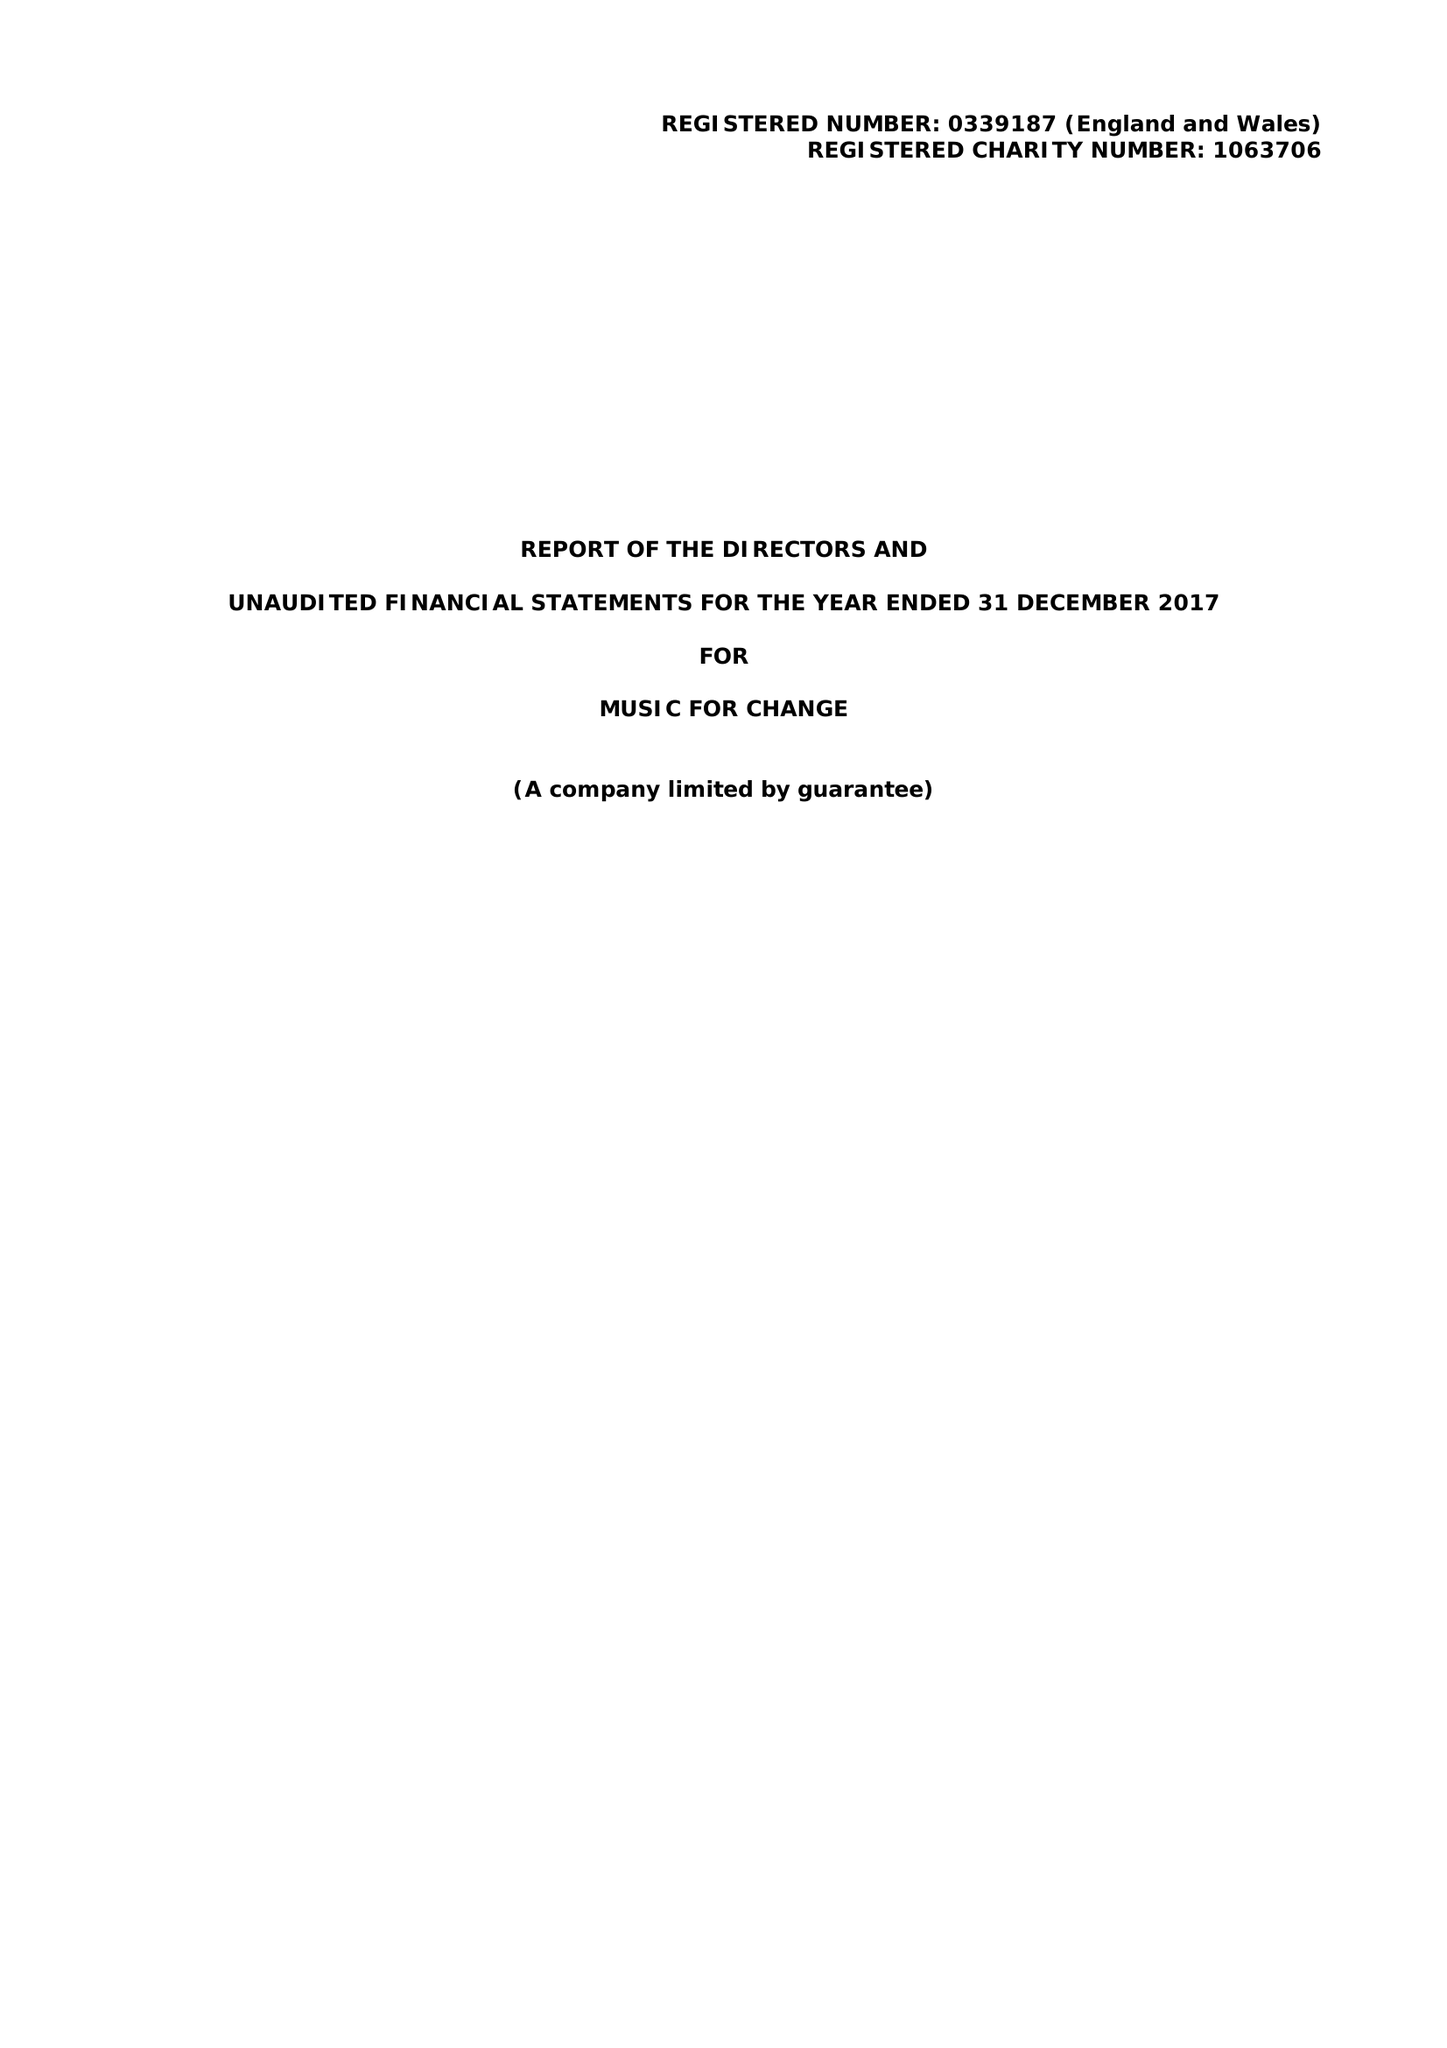What is the value for the report_date?
Answer the question using a single word or phrase. 2017-12-31 